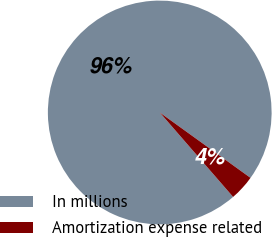Convert chart to OTSL. <chart><loc_0><loc_0><loc_500><loc_500><pie_chart><fcel>In millions<fcel>Amortization expense related<nl><fcel>96.32%<fcel>3.68%<nl></chart> 